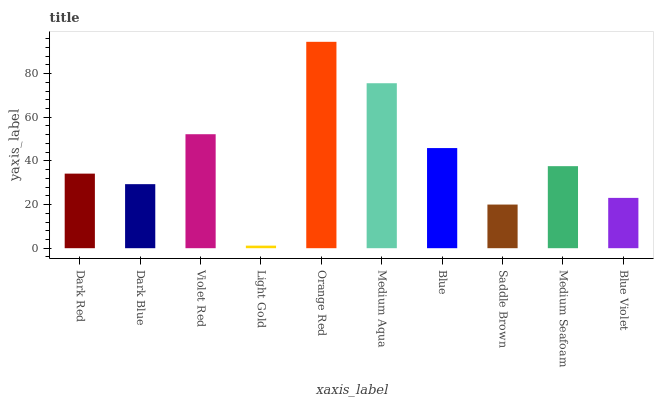Is Light Gold the minimum?
Answer yes or no. Yes. Is Orange Red the maximum?
Answer yes or no. Yes. Is Dark Blue the minimum?
Answer yes or no. No. Is Dark Blue the maximum?
Answer yes or no. No. Is Dark Red greater than Dark Blue?
Answer yes or no. Yes. Is Dark Blue less than Dark Red?
Answer yes or no. Yes. Is Dark Blue greater than Dark Red?
Answer yes or no. No. Is Dark Red less than Dark Blue?
Answer yes or no. No. Is Medium Seafoam the high median?
Answer yes or no. Yes. Is Dark Red the low median?
Answer yes or no. Yes. Is Light Gold the high median?
Answer yes or no. No. Is Dark Blue the low median?
Answer yes or no. No. 